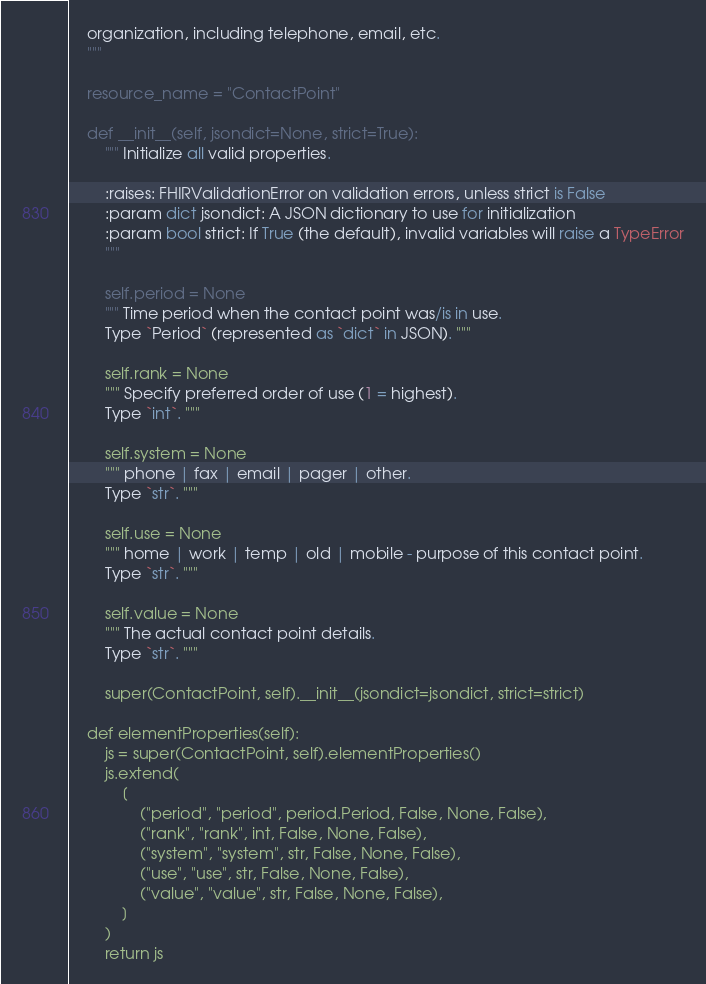<code> <loc_0><loc_0><loc_500><loc_500><_Python_>    organization, including telephone, email, etc.
    """

    resource_name = "ContactPoint"

    def __init__(self, jsondict=None, strict=True):
        """ Initialize all valid properties.
        
        :raises: FHIRValidationError on validation errors, unless strict is False
        :param dict jsondict: A JSON dictionary to use for initialization
        :param bool strict: If True (the default), invalid variables will raise a TypeError
        """

        self.period = None
        """ Time period when the contact point was/is in use.
        Type `Period` (represented as `dict` in JSON). """

        self.rank = None
        """ Specify preferred order of use (1 = highest).
        Type `int`. """

        self.system = None
        """ phone | fax | email | pager | other.
        Type `str`. """

        self.use = None
        """ home | work | temp | old | mobile - purpose of this contact point.
        Type `str`. """

        self.value = None
        """ The actual contact point details.
        Type `str`. """

        super(ContactPoint, self).__init__(jsondict=jsondict, strict=strict)

    def elementProperties(self):
        js = super(ContactPoint, self).elementProperties()
        js.extend(
            [
                ("period", "period", period.Period, False, None, False),
                ("rank", "rank", int, False, None, False),
                ("system", "system", str, False, None, False),
                ("use", "use", str, False, None, False),
                ("value", "value", str, False, None, False),
            ]
        )
        return js
</code> 